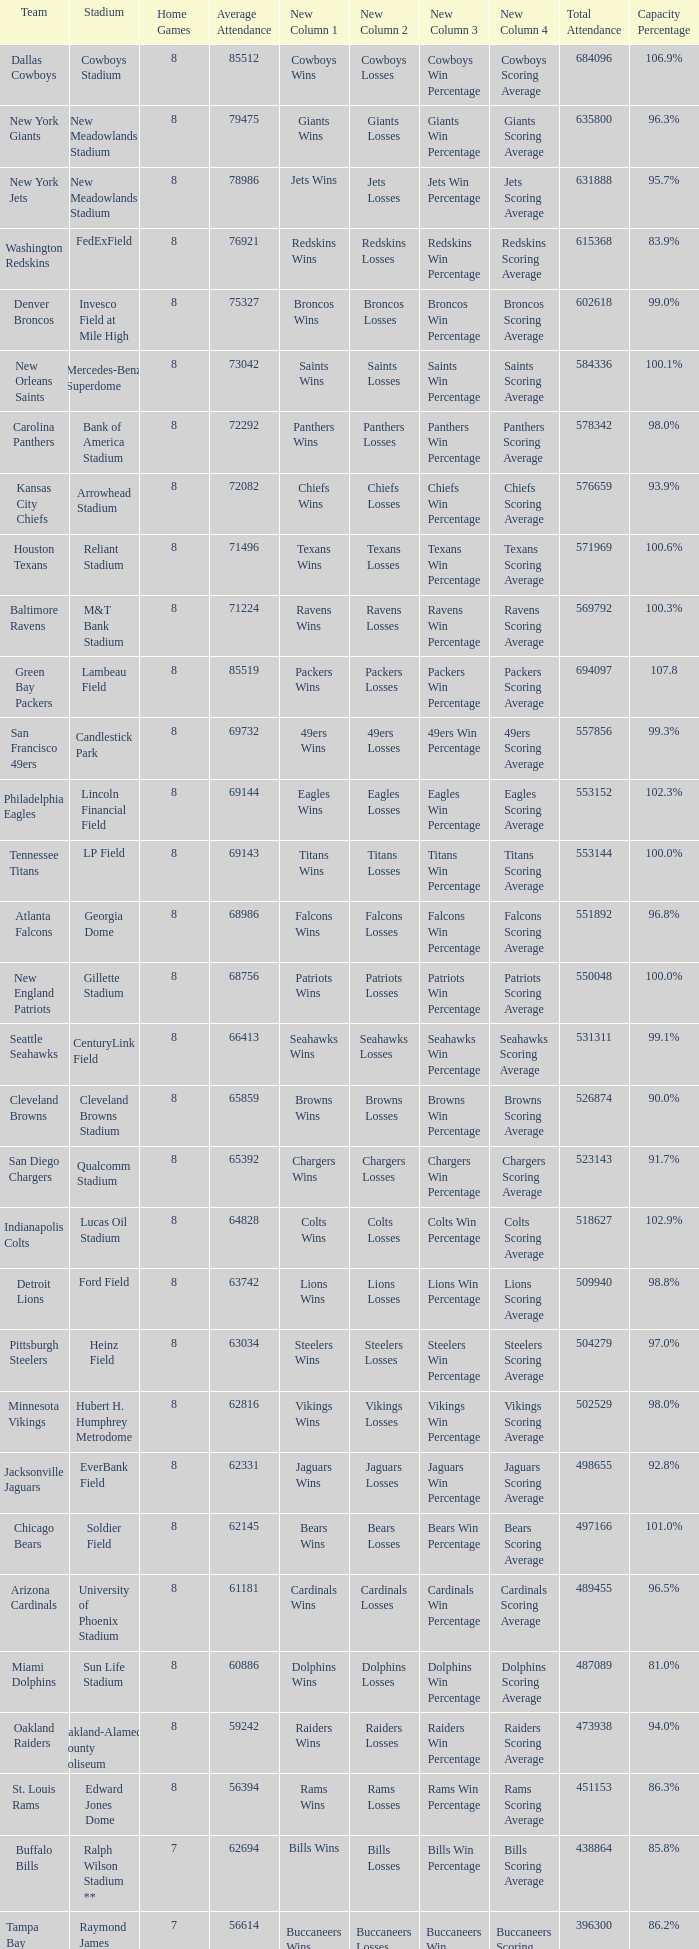How many average attendance has a capacity percentage of 96.5% 1.0. 